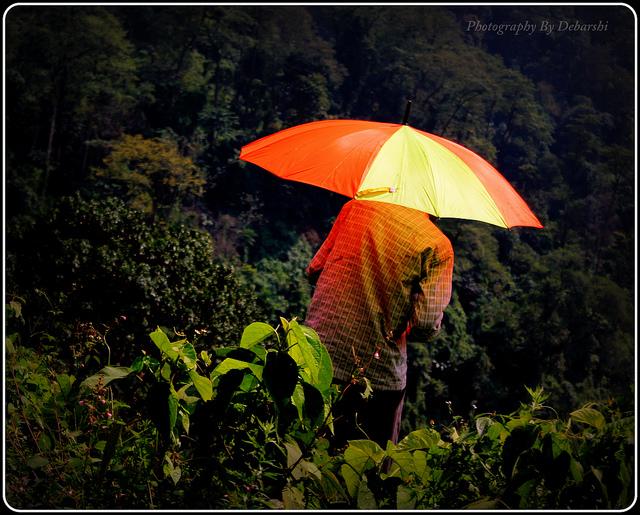Why can't you see the man's head?
Concise answer only. Umbrella. What pattern is on the man's shirt?
Short answer required. Checkered. What color is the umbrella?
Give a very brief answer. Orange and yellow. 